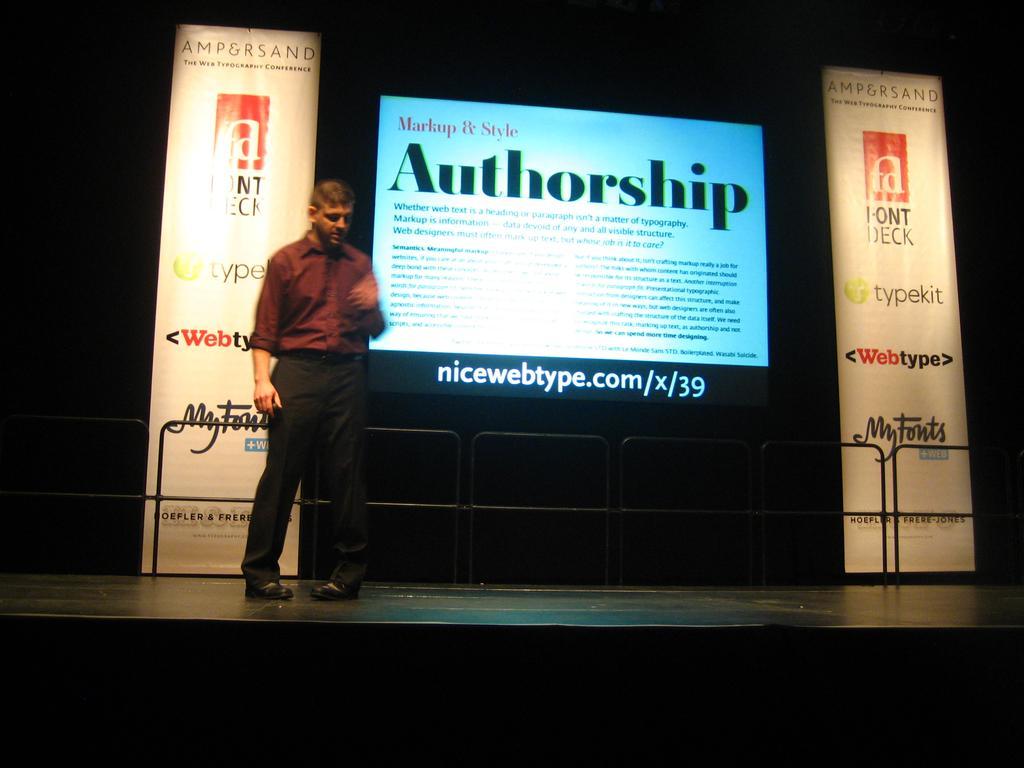Describe this image in one or two sentences. As we can see in the image there is a screen, banner and a person standing in the front. 